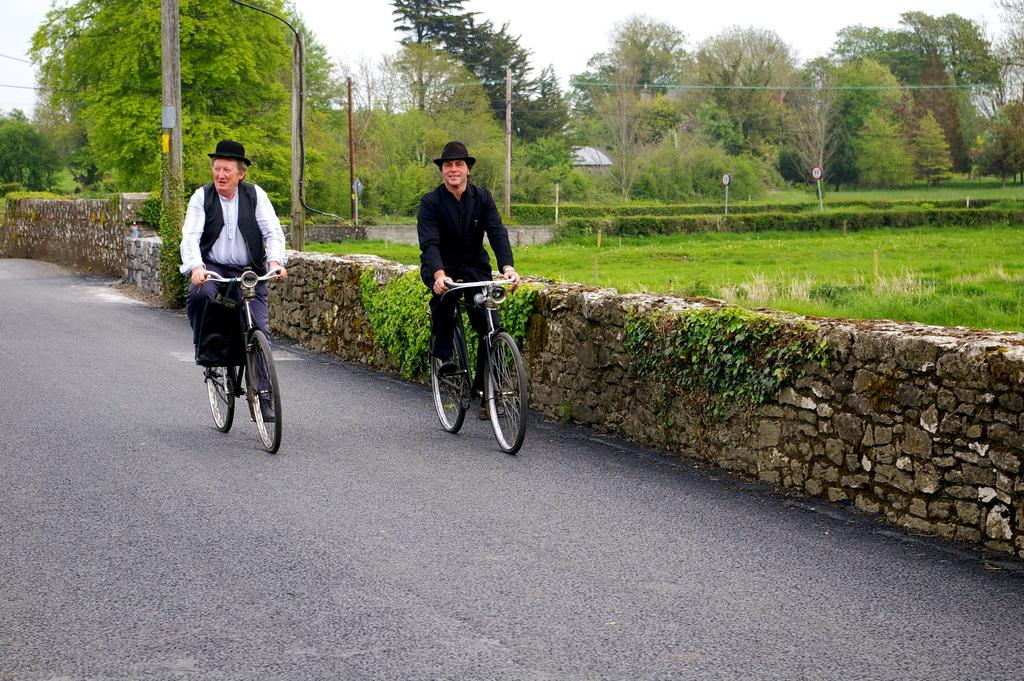Who is present in the image? There is a woman and a man in the image. What are they doing in the image? Both the woman and the man are riding a bicycle. Where are they located in the image? They are on a road. What can be seen in the background of the image? There are trees visible in the image. What type of train can be seen in the image? There is no train present in the image; it features a woman and a man riding a bicycle on a road. What kind of system is being used by the person in the image? There is no person mentioned in the image, only a woman and a man. Additionally, no system is visible or described in the image. 